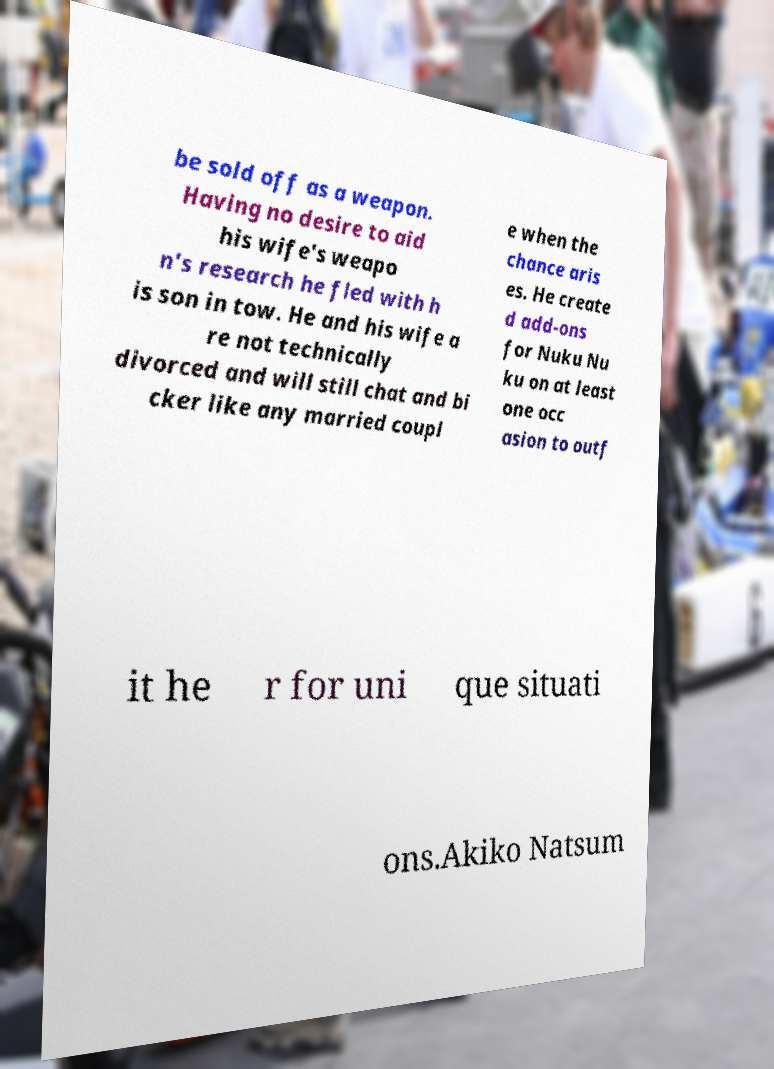I need the written content from this picture converted into text. Can you do that? be sold off as a weapon. Having no desire to aid his wife's weapo n's research he fled with h is son in tow. He and his wife a re not technically divorced and will still chat and bi cker like any married coupl e when the chance aris es. He create d add-ons for Nuku Nu ku on at least one occ asion to outf it he r for uni que situati ons.Akiko Natsum 